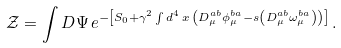<formula> <loc_0><loc_0><loc_500><loc_500>\mathcal { Z } = \int D \Psi \, e ^ { - \left [ S _ { 0 } + \gamma ^ { 2 } \int d ^ { 4 } \, x \, \left ( D _ { \mu } ^ { a b } \phi _ { \mu } ^ { b a } - s \left ( D _ { \mu } ^ { a b } \omega _ { \mu } ^ { b a } \right ) \right ) \right ] } \, .</formula> 